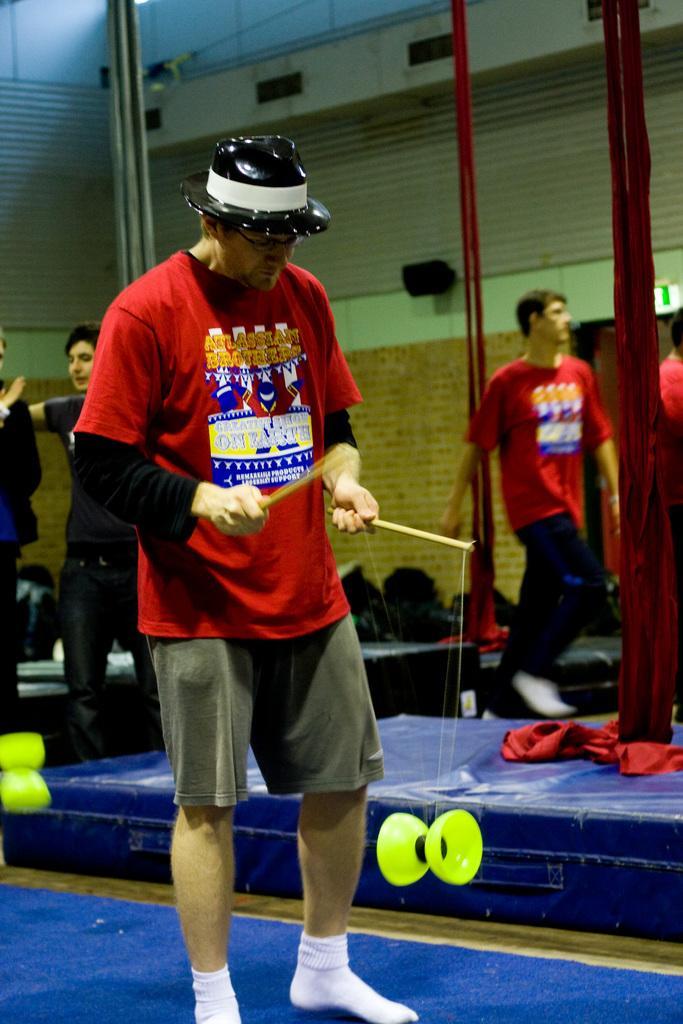Please provide a concise description of this image. In the image we can see there are people standing and a man is holding stick in his hand. 